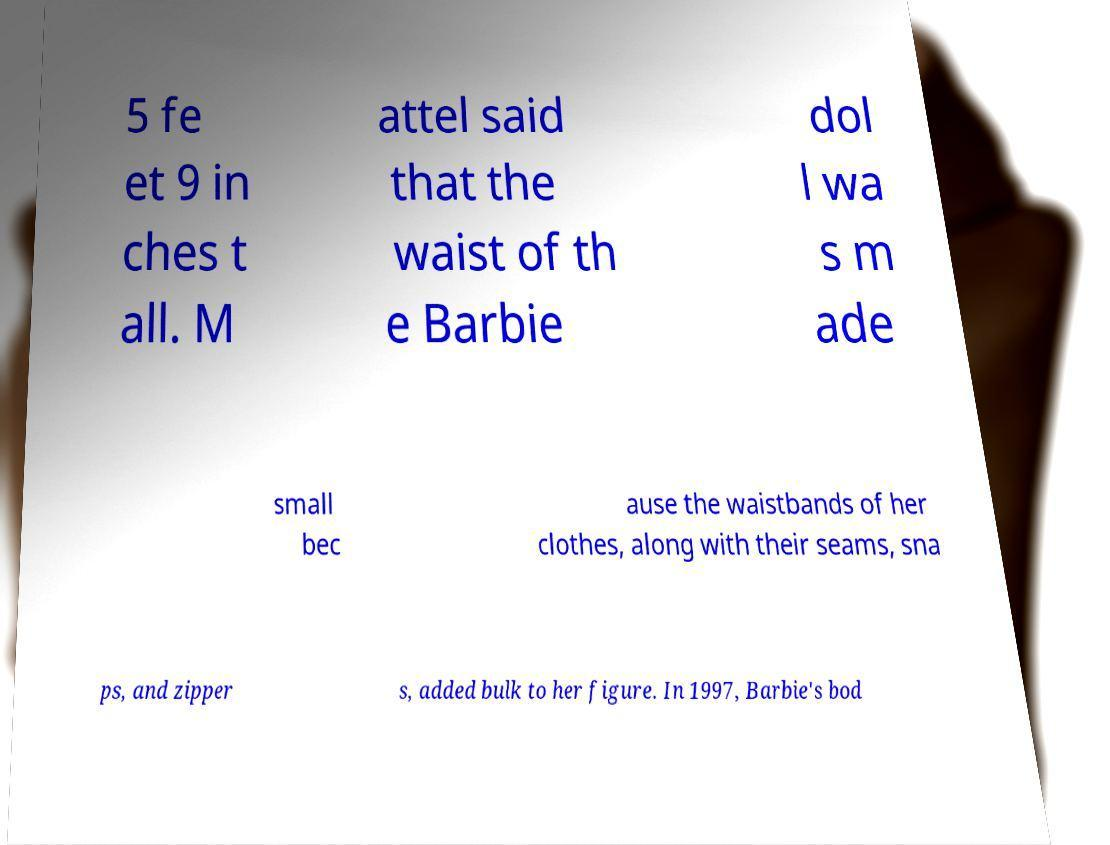I need the written content from this picture converted into text. Can you do that? 5 fe et 9 in ches t all. M attel said that the waist of th e Barbie dol l wa s m ade small bec ause the waistbands of her clothes, along with their seams, sna ps, and zipper s, added bulk to her figure. In 1997, Barbie's bod 